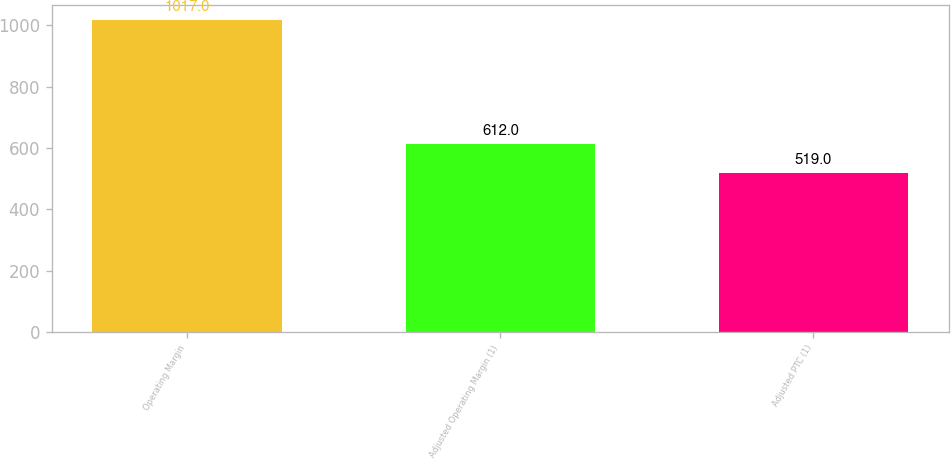Convert chart. <chart><loc_0><loc_0><loc_500><loc_500><bar_chart><fcel>Operating Margin<fcel>Adjusted Operating Margin (1)<fcel>Adjusted PTC (1)<nl><fcel>1017<fcel>612<fcel>519<nl></chart> 